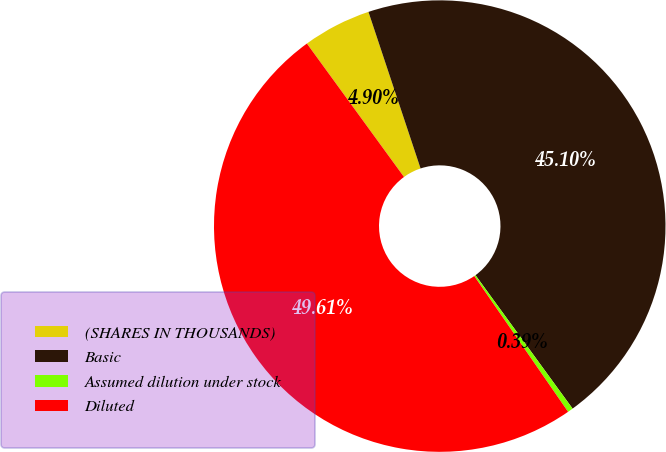Convert chart to OTSL. <chart><loc_0><loc_0><loc_500><loc_500><pie_chart><fcel>(SHARES IN THOUSANDS)<fcel>Basic<fcel>Assumed dilution under stock<fcel>Diluted<nl><fcel>4.9%<fcel>45.1%<fcel>0.39%<fcel>49.61%<nl></chart> 